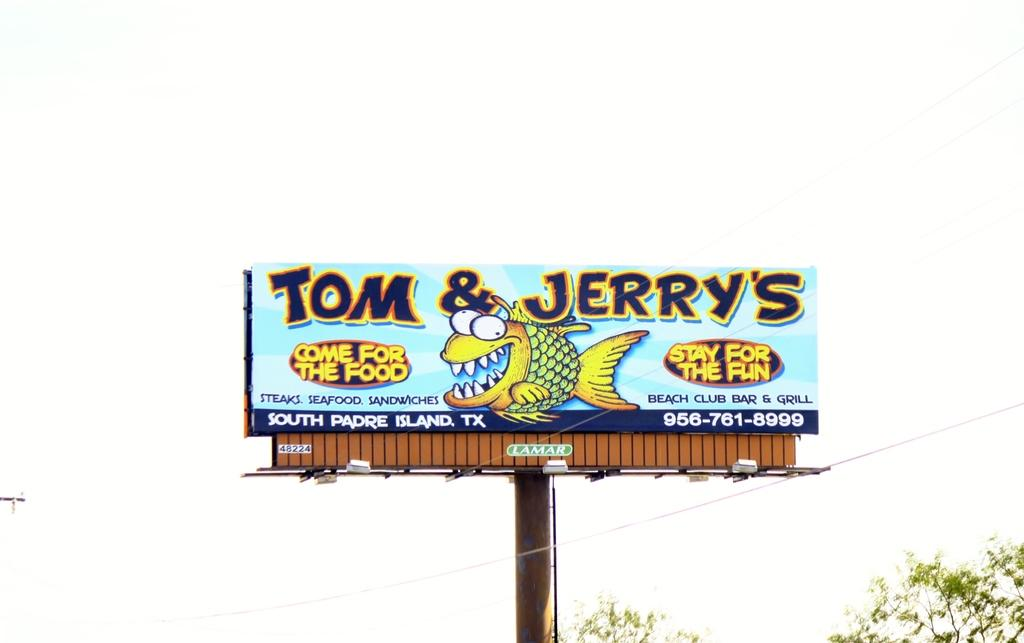<image>
Share a concise interpretation of the image provided. The billboard advertises Tom & Jerry's which serves steaks and seafood. 